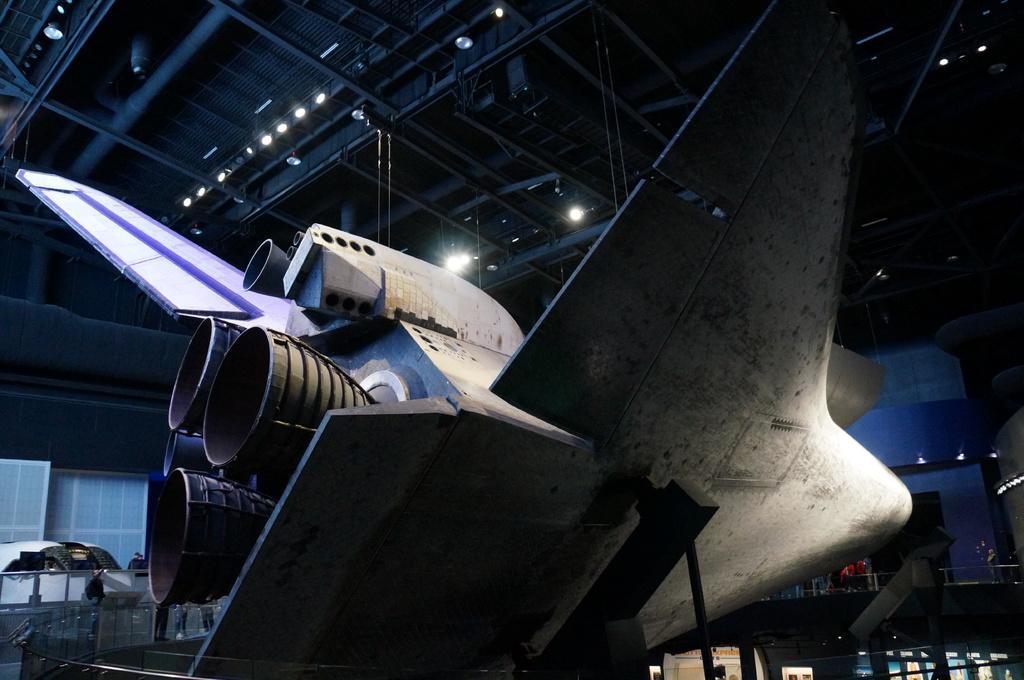Could you give a brief overview of what you see in this image? In this image we can see an inside view of a building. In the foreground we can see an airplane placed on stands. In the background, we can see group of persons standing on the floor, barricades, a device placed on the ground, group of lights and poles. 